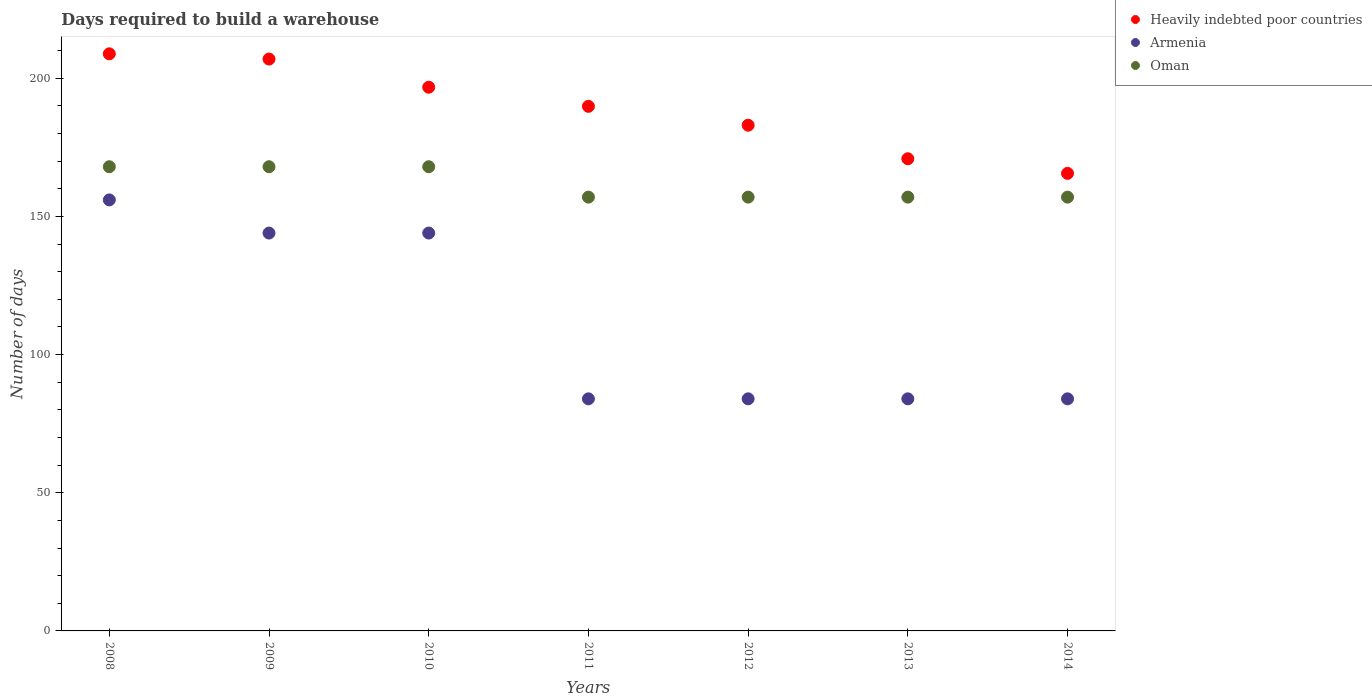What is the days required to build a warehouse in in Armenia in 2011?
Keep it short and to the point. 84. Across all years, what is the maximum days required to build a warehouse in in Oman?
Keep it short and to the point. 168. Across all years, what is the minimum days required to build a warehouse in in Oman?
Your answer should be very brief. 157. What is the total days required to build a warehouse in in Heavily indebted poor countries in the graph?
Your response must be concise. 1322. What is the difference between the days required to build a warehouse in in Heavily indebted poor countries in 2009 and that in 2010?
Your response must be concise. 10.19. What is the difference between the days required to build a warehouse in in Oman in 2011 and the days required to build a warehouse in in Armenia in 2009?
Provide a short and direct response. 13. What is the average days required to build a warehouse in in Heavily indebted poor countries per year?
Your answer should be compact. 188.86. In the year 2013, what is the difference between the days required to build a warehouse in in Heavily indebted poor countries and days required to build a warehouse in in Armenia?
Ensure brevity in your answer.  86.89. In how many years, is the days required to build a warehouse in in Armenia greater than 10 days?
Make the answer very short. 7. What is the ratio of the days required to build a warehouse in in Heavily indebted poor countries in 2009 to that in 2014?
Give a very brief answer. 1.25. Is the days required to build a warehouse in in Armenia in 2008 less than that in 2009?
Your response must be concise. No. What is the difference between the highest and the lowest days required to build a warehouse in in Heavily indebted poor countries?
Make the answer very short. 43.27. Is the sum of the days required to build a warehouse in in Oman in 2010 and 2014 greater than the maximum days required to build a warehouse in in Armenia across all years?
Ensure brevity in your answer.  Yes. Is it the case that in every year, the sum of the days required to build a warehouse in in Oman and days required to build a warehouse in in Heavily indebted poor countries  is greater than the days required to build a warehouse in in Armenia?
Your answer should be compact. Yes. Does the days required to build a warehouse in in Armenia monotonically increase over the years?
Offer a very short reply. No. Is the days required to build a warehouse in in Oman strictly less than the days required to build a warehouse in in Armenia over the years?
Provide a short and direct response. No. Does the graph contain grids?
Offer a very short reply. No. How many legend labels are there?
Your answer should be very brief. 3. What is the title of the graph?
Make the answer very short. Days required to build a warehouse. Does "Portugal" appear as one of the legend labels in the graph?
Offer a very short reply. No. What is the label or title of the Y-axis?
Your answer should be very brief. Number of days. What is the Number of days of Heavily indebted poor countries in 2008?
Provide a short and direct response. 208.86. What is the Number of days in Armenia in 2008?
Keep it short and to the point. 156. What is the Number of days in Oman in 2008?
Ensure brevity in your answer.  168. What is the Number of days in Heavily indebted poor countries in 2009?
Offer a terse response. 206.97. What is the Number of days in Armenia in 2009?
Offer a terse response. 144. What is the Number of days in Oman in 2009?
Provide a succinct answer. 168. What is the Number of days of Heavily indebted poor countries in 2010?
Your response must be concise. 196.78. What is the Number of days in Armenia in 2010?
Ensure brevity in your answer.  144. What is the Number of days in Oman in 2010?
Your answer should be compact. 168. What is the Number of days of Heavily indebted poor countries in 2011?
Provide a succinct answer. 189.86. What is the Number of days in Armenia in 2011?
Offer a very short reply. 84. What is the Number of days of Oman in 2011?
Offer a terse response. 157. What is the Number of days in Heavily indebted poor countries in 2012?
Your response must be concise. 183.03. What is the Number of days in Oman in 2012?
Offer a very short reply. 157. What is the Number of days in Heavily indebted poor countries in 2013?
Your answer should be very brief. 170.89. What is the Number of days in Oman in 2013?
Give a very brief answer. 157. What is the Number of days of Heavily indebted poor countries in 2014?
Offer a very short reply. 165.59. What is the Number of days of Oman in 2014?
Give a very brief answer. 157. Across all years, what is the maximum Number of days of Heavily indebted poor countries?
Provide a short and direct response. 208.86. Across all years, what is the maximum Number of days in Armenia?
Give a very brief answer. 156. Across all years, what is the maximum Number of days of Oman?
Keep it short and to the point. 168. Across all years, what is the minimum Number of days of Heavily indebted poor countries?
Ensure brevity in your answer.  165.59. Across all years, what is the minimum Number of days in Armenia?
Keep it short and to the point. 84. Across all years, what is the minimum Number of days of Oman?
Keep it short and to the point. 157. What is the total Number of days of Heavily indebted poor countries in the graph?
Make the answer very short. 1322. What is the total Number of days in Armenia in the graph?
Provide a short and direct response. 780. What is the total Number of days in Oman in the graph?
Offer a terse response. 1132. What is the difference between the Number of days in Heavily indebted poor countries in 2008 and that in 2009?
Provide a succinct answer. 1.89. What is the difference between the Number of days in Oman in 2008 and that in 2009?
Your response must be concise. 0. What is the difference between the Number of days in Heavily indebted poor countries in 2008 and that in 2010?
Your answer should be compact. 12.08. What is the difference between the Number of days in Armenia in 2008 and that in 2010?
Offer a very short reply. 12. What is the difference between the Number of days of Oman in 2008 and that in 2010?
Make the answer very short. 0. What is the difference between the Number of days of Heavily indebted poor countries in 2008 and that in 2011?
Provide a succinct answer. 19. What is the difference between the Number of days of Heavily indebted poor countries in 2008 and that in 2012?
Your answer should be very brief. 25.84. What is the difference between the Number of days of Armenia in 2008 and that in 2012?
Provide a succinct answer. 72. What is the difference between the Number of days of Heavily indebted poor countries in 2008 and that in 2013?
Make the answer very short. 37.97. What is the difference between the Number of days of Heavily indebted poor countries in 2008 and that in 2014?
Offer a terse response. 43.27. What is the difference between the Number of days in Oman in 2008 and that in 2014?
Your answer should be compact. 11. What is the difference between the Number of days in Heavily indebted poor countries in 2009 and that in 2010?
Your response must be concise. 10.19. What is the difference between the Number of days in Oman in 2009 and that in 2010?
Make the answer very short. 0. What is the difference between the Number of days of Heavily indebted poor countries in 2009 and that in 2011?
Give a very brief answer. 17.11. What is the difference between the Number of days of Heavily indebted poor countries in 2009 and that in 2012?
Keep it short and to the point. 23.95. What is the difference between the Number of days in Armenia in 2009 and that in 2012?
Keep it short and to the point. 60. What is the difference between the Number of days in Heavily indebted poor countries in 2009 and that in 2013?
Give a very brief answer. 36.08. What is the difference between the Number of days in Armenia in 2009 and that in 2013?
Ensure brevity in your answer.  60. What is the difference between the Number of days of Oman in 2009 and that in 2013?
Offer a terse response. 11. What is the difference between the Number of days of Heavily indebted poor countries in 2009 and that in 2014?
Ensure brevity in your answer.  41.38. What is the difference between the Number of days in Heavily indebted poor countries in 2010 and that in 2011?
Offer a terse response. 6.92. What is the difference between the Number of days of Heavily indebted poor countries in 2010 and that in 2012?
Keep it short and to the point. 13.76. What is the difference between the Number of days of Heavily indebted poor countries in 2010 and that in 2013?
Provide a short and direct response. 25.89. What is the difference between the Number of days in Armenia in 2010 and that in 2013?
Provide a short and direct response. 60. What is the difference between the Number of days in Oman in 2010 and that in 2013?
Offer a very short reply. 11. What is the difference between the Number of days in Heavily indebted poor countries in 2010 and that in 2014?
Ensure brevity in your answer.  31.19. What is the difference between the Number of days in Armenia in 2010 and that in 2014?
Offer a terse response. 60. What is the difference between the Number of days in Heavily indebted poor countries in 2011 and that in 2012?
Provide a short and direct response. 6.84. What is the difference between the Number of days of Oman in 2011 and that in 2012?
Offer a very short reply. 0. What is the difference between the Number of days of Heavily indebted poor countries in 2011 and that in 2013?
Provide a short and direct response. 18.97. What is the difference between the Number of days in Oman in 2011 and that in 2013?
Your answer should be very brief. 0. What is the difference between the Number of days in Heavily indebted poor countries in 2011 and that in 2014?
Ensure brevity in your answer.  24.27. What is the difference between the Number of days of Armenia in 2011 and that in 2014?
Make the answer very short. 0. What is the difference between the Number of days of Heavily indebted poor countries in 2012 and that in 2013?
Offer a very short reply. 12.14. What is the difference between the Number of days of Heavily indebted poor countries in 2012 and that in 2014?
Provide a succinct answer. 17.43. What is the difference between the Number of days in Armenia in 2012 and that in 2014?
Your answer should be compact. 0. What is the difference between the Number of days of Oman in 2012 and that in 2014?
Provide a succinct answer. 0. What is the difference between the Number of days in Heavily indebted poor countries in 2013 and that in 2014?
Offer a terse response. 5.3. What is the difference between the Number of days of Heavily indebted poor countries in 2008 and the Number of days of Armenia in 2009?
Provide a short and direct response. 64.86. What is the difference between the Number of days in Heavily indebted poor countries in 2008 and the Number of days in Oman in 2009?
Your response must be concise. 40.86. What is the difference between the Number of days of Armenia in 2008 and the Number of days of Oman in 2009?
Offer a terse response. -12. What is the difference between the Number of days of Heavily indebted poor countries in 2008 and the Number of days of Armenia in 2010?
Keep it short and to the point. 64.86. What is the difference between the Number of days in Heavily indebted poor countries in 2008 and the Number of days in Oman in 2010?
Ensure brevity in your answer.  40.86. What is the difference between the Number of days in Heavily indebted poor countries in 2008 and the Number of days in Armenia in 2011?
Provide a short and direct response. 124.86. What is the difference between the Number of days of Heavily indebted poor countries in 2008 and the Number of days of Oman in 2011?
Offer a very short reply. 51.86. What is the difference between the Number of days in Armenia in 2008 and the Number of days in Oman in 2011?
Your answer should be compact. -1. What is the difference between the Number of days in Heavily indebted poor countries in 2008 and the Number of days in Armenia in 2012?
Your answer should be compact. 124.86. What is the difference between the Number of days in Heavily indebted poor countries in 2008 and the Number of days in Oman in 2012?
Your answer should be compact. 51.86. What is the difference between the Number of days of Heavily indebted poor countries in 2008 and the Number of days of Armenia in 2013?
Ensure brevity in your answer.  124.86. What is the difference between the Number of days in Heavily indebted poor countries in 2008 and the Number of days in Oman in 2013?
Keep it short and to the point. 51.86. What is the difference between the Number of days in Armenia in 2008 and the Number of days in Oman in 2013?
Provide a short and direct response. -1. What is the difference between the Number of days of Heavily indebted poor countries in 2008 and the Number of days of Armenia in 2014?
Your response must be concise. 124.86. What is the difference between the Number of days of Heavily indebted poor countries in 2008 and the Number of days of Oman in 2014?
Your answer should be very brief. 51.86. What is the difference between the Number of days in Armenia in 2008 and the Number of days in Oman in 2014?
Make the answer very short. -1. What is the difference between the Number of days in Heavily indebted poor countries in 2009 and the Number of days in Armenia in 2010?
Offer a very short reply. 62.97. What is the difference between the Number of days of Heavily indebted poor countries in 2009 and the Number of days of Oman in 2010?
Keep it short and to the point. 38.97. What is the difference between the Number of days in Armenia in 2009 and the Number of days in Oman in 2010?
Your response must be concise. -24. What is the difference between the Number of days of Heavily indebted poor countries in 2009 and the Number of days of Armenia in 2011?
Your answer should be very brief. 122.97. What is the difference between the Number of days of Heavily indebted poor countries in 2009 and the Number of days of Oman in 2011?
Your response must be concise. 49.97. What is the difference between the Number of days of Armenia in 2009 and the Number of days of Oman in 2011?
Your answer should be very brief. -13. What is the difference between the Number of days in Heavily indebted poor countries in 2009 and the Number of days in Armenia in 2012?
Offer a terse response. 122.97. What is the difference between the Number of days in Heavily indebted poor countries in 2009 and the Number of days in Oman in 2012?
Provide a short and direct response. 49.97. What is the difference between the Number of days in Heavily indebted poor countries in 2009 and the Number of days in Armenia in 2013?
Keep it short and to the point. 122.97. What is the difference between the Number of days of Heavily indebted poor countries in 2009 and the Number of days of Oman in 2013?
Keep it short and to the point. 49.97. What is the difference between the Number of days in Armenia in 2009 and the Number of days in Oman in 2013?
Your answer should be compact. -13. What is the difference between the Number of days in Heavily indebted poor countries in 2009 and the Number of days in Armenia in 2014?
Give a very brief answer. 122.97. What is the difference between the Number of days of Heavily indebted poor countries in 2009 and the Number of days of Oman in 2014?
Your answer should be very brief. 49.97. What is the difference between the Number of days of Heavily indebted poor countries in 2010 and the Number of days of Armenia in 2011?
Offer a terse response. 112.78. What is the difference between the Number of days of Heavily indebted poor countries in 2010 and the Number of days of Oman in 2011?
Your answer should be compact. 39.78. What is the difference between the Number of days in Heavily indebted poor countries in 2010 and the Number of days in Armenia in 2012?
Ensure brevity in your answer.  112.78. What is the difference between the Number of days of Heavily indebted poor countries in 2010 and the Number of days of Oman in 2012?
Keep it short and to the point. 39.78. What is the difference between the Number of days of Heavily indebted poor countries in 2010 and the Number of days of Armenia in 2013?
Provide a short and direct response. 112.78. What is the difference between the Number of days in Heavily indebted poor countries in 2010 and the Number of days in Oman in 2013?
Offer a terse response. 39.78. What is the difference between the Number of days in Armenia in 2010 and the Number of days in Oman in 2013?
Keep it short and to the point. -13. What is the difference between the Number of days of Heavily indebted poor countries in 2010 and the Number of days of Armenia in 2014?
Give a very brief answer. 112.78. What is the difference between the Number of days in Heavily indebted poor countries in 2010 and the Number of days in Oman in 2014?
Offer a very short reply. 39.78. What is the difference between the Number of days in Heavily indebted poor countries in 2011 and the Number of days in Armenia in 2012?
Ensure brevity in your answer.  105.86. What is the difference between the Number of days in Heavily indebted poor countries in 2011 and the Number of days in Oman in 2012?
Your response must be concise. 32.86. What is the difference between the Number of days in Armenia in 2011 and the Number of days in Oman in 2012?
Keep it short and to the point. -73. What is the difference between the Number of days in Heavily indebted poor countries in 2011 and the Number of days in Armenia in 2013?
Keep it short and to the point. 105.86. What is the difference between the Number of days of Heavily indebted poor countries in 2011 and the Number of days of Oman in 2013?
Your response must be concise. 32.86. What is the difference between the Number of days in Armenia in 2011 and the Number of days in Oman in 2013?
Your response must be concise. -73. What is the difference between the Number of days of Heavily indebted poor countries in 2011 and the Number of days of Armenia in 2014?
Keep it short and to the point. 105.86. What is the difference between the Number of days of Heavily indebted poor countries in 2011 and the Number of days of Oman in 2014?
Provide a short and direct response. 32.86. What is the difference between the Number of days in Armenia in 2011 and the Number of days in Oman in 2014?
Ensure brevity in your answer.  -73. What is the difference between the Number of days in Heavily indebted poor countries in 2012 and the Number of days in Armenia in 2013?
Your answer should be compact. 99.03. What is the difference between the Number of days of Heavily indebted poor countries in 2012 and the Number of days of Oman in 2013?
Your response must be concise. 26.03. What is the difference between the Number of days in Armenia in 2012 and the Number of days in Oman in 2013?
Make the answer very short. -73. What is the difference between the Number of days of Heavily indebted poor countries in 2012 and the Number of days of Armenia in 2014?
Give a very brief answer. 99.03. What is the difference between the Number of days of Heavily indebted poor countries in 2012 and the Number of days of Oman in 2014?
Offer a terse response. 26.03. What is the difference between the Number of days in Armenia in 2012 and the Number of days in Oman in 2014?
Provide a succinct answer. -73. What is the difference between the Number of days in Heavily indebted poor countries in 2013 and the Number of days in Armenia in 2014?
Give a very brief answer. 86.89. What is the difference between the Number of days of Heavily indebted poor countries in 2013 and the Number of days of Oman in 2014?
Offer a terse response. 13.89. What is the difference between the Number of days of Armenia in 2013 and the Number of days of Oman in 2014?
Make the answer very short. -73. What is the average Number of days in Heavily indebted poor countries per year?
Ensure brevity in your answer.  188.86. What is the average Number of days in Armenia per year?
Make the answer very short. 111.43. What is the average Number of days of Oman per year?
Your response must be concise. 161.71. In the year 2008, what is the difference between the Number of days of Heavily indebted poor countries and Number of days of Armenia?
Make the answer very short. 52.86. In the year 2008, what is the difference between the Number of days of Heavily indebted poor countries and Number of days of Oman?
Keep it short and to the point. 40.86. In the year 2009, what is the difference between the Number of days in Heavily indebted poor countries and Number of days in Armenia?
Provide a short and direct response. 62.97. In the year 2009, what is the difference between the Number of days of Heavily indebted poor countries and Number of days of Oman?
Give a very brief answer. 38.97. In the year 2009, what is the difference between the Number of days of Armenia and Number of days of Oman?
Your answer should be compact. -24. In the year 2010, what is the difference between the Number of days of Heavily indebted poor countries and Number of days of Armenia?
Ensure brevity in your answer.  52.78. In the year 2010, what is the difference between the Number of days of Heavily indebted poor countries and Number of days of Oman?
Make the answer very short. 28.78. In the year 2011, what is the difference between the Number of days of Heavily indebted poor countries and Number of days of Armenia?
Your response must be concise. 105.86. In the year 2011, what is the difference between the Number of days of Heavily indebted poor countries and Number of days of Oman?
Give a very brief answer. 32.86. In the year 2011, what is the difference between the Number of days of Armenia and Number of days of Oman?
Your response must be concise. -73. In the year 2012, what is the difference between the Number of days of Heavily indebted poor countries and Number of days of Armenia?
Provide a short and direct response. 99.03. In the year 2012, what is the difference between the Number of days in Heavily indebted poor countries and Number of days in Oman?
Provide a short and direct response. 26.03. In the year 2012, what is the difference between the Number of days in Armenia and Number of days in Oman?
Ensure brevity in your answer.  -73. In the year 2013, what is the difference between the Number of days of Heavily indebted poor countries and Number of days of Armenia?
Ensure brevity in your answer.  86.89. In the year 2013, what is the difference between the Number of days of Heavily indebted poor countries and Number of days of Oman?
Make the answer very short. 13.89. In the year 2013, what is the difference between the Number of days of Armenia and Number of days of Oman?
Your answer should be compact. -73. In the year 2014, what is the difference between the Number of days of Heavily indebted poor countries and Number of days of Armenia?
Provide a short and direct response. 81.59. In the year 2014, what is the difference between the Number of days of Heavily indebted poor countries and Number of days of Oman?
Your answer should be compact. 8.59. In the year 2014, what is the difference between the Number of days of Armenia and Number of days of Oman?
Your response must be concise. -73. What is the ratio of the Number of days of Heavily indebted poor countries in 2008 to that in 2009?
Your answer should be very brief. 1.01. What is the ratio of the Number of days of Armenia in 2008 to that in 2009?
Your answer should be compact. 1.08. What is the ratio of the Number of days of Oman in 2008 to that in 2009?
Your response must be concise. 1. What is the ratio of the Number of days of Heavily indebted poor countries in 2008 to that in 2010?
Give a very brief answer. 1.06. What is the ratio of the Number of days in Armenia in 2008 to that in 2010?
Offer a terse response. 1.08. What is the ratio of the Number of days of Oman in 2008 to that in 2010?
Ensure brevity in your answer.  1. What is the ratio of the Number of days of Heavily indebted poor countries in 2008 to that in 2011?
Provide a short and direct response. 1.1. What is the ratio of the Number of days of Armenia in 2008 to that in 2011?
Provide a succinct answer. 1.86. What is the ratio of the Number of days in Oman in 2008 to that in 2011?
Keep it short and to the point. 1.07. What is the ratio of the Number of days in Heavily indebted poor countries in 2008 to that in 2012?
Offer a very short reply. 1.14. What is the ratio of the Number of days in Armenia in 2008 to that in 2012?
Ensure brevity in your answer.  1.86. What is the ratio of the Number of days of Oman in 2008 to that in 2012?
Provide a short and direct response. 1.07. What is the ratio of the Number of days in Heavily indebted poor countries in 2008 to that in 2013?
Offer a terse response. 1.22. What is the ratio of the Number of days of Armenia in 2008 to that in 2013?
Keep it short and to the point. 1.86. What is the ratio of the Number of days of Oman in 2008 to that in 2013?
Your response must be concise. 1.07. What is the ratio of the Number of days in Heavily indebted poor countries in 2008 to that in 2014?
Ensure brevity in your answer.  1.26. What is the ratio of the Number of days of Armenia in 2008 to that in 2014?
Give a very brief answer. 1.86. What is the ratio of the Number of days in Oman in 2008 to that in 2014?
Offer a terse response. 1.07. What is the ratio of the Number of days of Heavily indebted poor countries in 2009 to that in 2010?
Ensure brevity in your answer.  1.05. What is the ratio of the Number of days in Armenia in 2009 to that in 2010?
Keep it short and to the point. 1. What is the ratio of the Number of days of Heavily indebted poor countries in 2009 to that in 2011?
Make the answer very short. 1.09. What is the ratio of the Number of days of Armenia in 2009 to that in 2011?
Your response must be concise. 1.71. What is the ratio of the Number of days of Oman in 2009 to that in 2011?
Provide a succinct answer. 1.07. What is the ratio of the Number of days in Heavily indebted poor countries in 2009 to that in 2012?
Ensure brevity in your answer.  1.13. What is the ratio of the Number of days in Armenia in 2009 to that in 2012?
Provide a short and direct response. 1.71. What is the ratio of the Number of days in Oman in 2009 to that in 2012?
Provide a succinct answer. 1.07. What is the ratio of the Number of days of Heavily indebted poor countries in 2009 to that in 2013?
Your answer should be compact. 1.21. What is the ratio of the Number of days of Armenia in 2009 to that in 2013?
Provide a short and direct response. 1.71. What is the ratio of the Number of days of Oman in 2009 to that in 2013?
Provide a succinct answer. 1.07. What is the ratio of the Number of days of Heavily indebted poor countries in 2009 to that in 2014?
Your answer should be very brief. 1.25. What is the ratio of the Number of days in Armenia in 2009 to that in 2014?
Your response must be concise. 1.71. What is the ratio of the Number of days in Oman in 2009 to that in 2014?
Your answer should be very brief. 1.07. What is the ratio of the Number of days of Heavily indebted poor countries in 2010 to that in 2011?
Your answer should be compact. 1.04. What is the ratio of the Number of days of Armenia in 2010 to that in 2011?
Offer a terse response. 1.71. What is the ratio of the Number of days in Oman in 2010 to that in 2011?
Your answer should be very brief. 1.07. What is the ratio of the Number of days of Heavily indebted poor countries in 2010 to that in 2012?
Ensure brevity in your answer.  1.08. What is the ratio of the Number of days of Armenia in 2010 to that in 2012?
Your answer should be very brief. 1.71. What is the ratio of the Number of days in Oman in 2010 to that in 2012?
Provide a short and direct response. 1.07. What is the ratio of the Number of days in Heavily indebted poor countries in 2010 to that in 2013?
Ensure brevity in your answer.  1.15. What is the ratio of the Number of days of Armenia in 2010 to that in 2013?
Provide a succinct answer. 1.71. What is the ratio of the Number of days of Oman in 2010 to that in 2013?
Offer a terse response. 1.07. What is the ratio of the Number of days of Heavily indebted poor countries in 2010 to that in 2014?
Provide a short and direct response. 1.19. What is the ratio of the Number of days in Armenia in 2010 to that in 2014?
Make the answer very short. 1.71. What is the ratio of the Number of days of Oman in 2010 to that in 2014?
Offer a terse response. 1.07. What is the ratio of the Number of days of Heavily indebted poor countries in 2011 to that in 2012?
Ensure brevity in your answer.  1.04. What is the ratio of the Number of days of Armenia in 2011 to that in 2012?
Your answer should be compact. 1. What is the ratio of the Number of days in Oman in 2011 to that in 2012?
Ensure brevity in your answer.  1. What is the ratio of the Number of days of Heavily indebted poor countries in 2011 to that in 2013?
Your response must be concise. 1.11. What is the ratio of the Number of days in Oman in 2011 to that in 2013?
Provide a short and direct response. 1. What is the ratio of the Number of days in Heavily indebted poor countries in 2011 to that in 2014?
Offer a terse response. 1.15. What is the ratio of the Number of days in Heavily indebted poor countries in 2012 to that in 2013?
Provide a succinct answer. 1.07. What is the ratio of the Number of days in Oman in 2012 to that in 2013?
Provide a succinct answer. 1. What is the ratio of the Number of days in Heavily indebted poor countries in 2012 to that in 2014?
Give a very brief answer. 1.11. What is the ratio of the Number of days of Armenia in 2012 to that in 2014?
Give a very brief answer. 1. What is the ratio of the Number of days of Oman in 2012 to that in 2014?
Provide a short and direct response. 1. What is the ratio of the Number of days of Heavily indebted poor countries in 2013 to that in 2014?
Your answer should be compact. 1.03. What is the ratio of the Number of days in Oman in 2013 to that in 2014?
Ensure brevity in your answer.  1. What is the difference between the highest and the second highest Number of days in Heavily indebted poor countries?
Ensure brevity in your answer.  1.89. What is the difference between the highest and the second highest Number of days of Oman?
Your answer should be compact. 0. What is the difference between the highest and the lowest Number of days of Heavily indebted poor countries?
Your response must be concise. 43.27. What is the difference between the highest and the lowest Number of days in Armenia?
Make the answer very short. 72. 